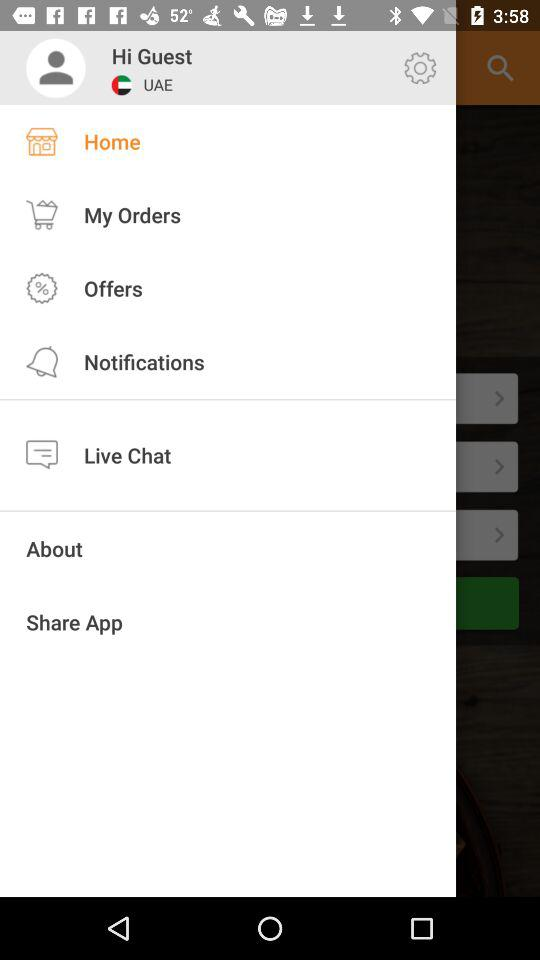Which item is selected in the menu? The item "Home" is selected in the menu. 